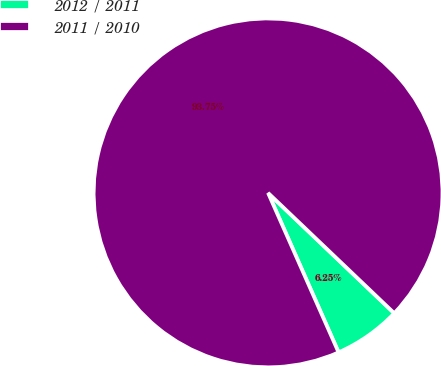Convert chart. <chart><loc_0><loc_0><loc_500><loc_500><pie_chart><fcel>2012 / 2011<fcel>2011 / 2010<nl><fcel>6.25%<fcel>93.75%<nl></chart> 